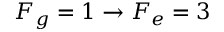Convert formula to latex. <formula><loc_0><loc_0><loc_500><loc_500>F _ { g } = 1 \rightarrow F _ { e } = 3</formula> 